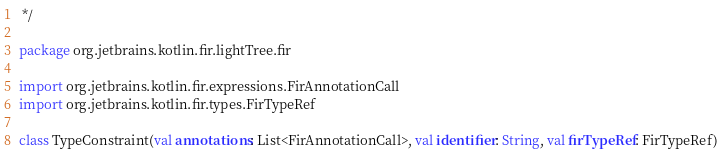Convert code to text. <code><loc_0><loc_0><loc_500><loc_500><_Kotlin_> */

package org.jetbrains.kotlin.fir.lightTree.fir

import org.jetbrains.kotlin.fir.expressions.FirAnnotationCall
import org.jetbrains.kotlin.fir.types.FirTypeRef

class TypeConstraint(val annotations: List<FirAnnotationCall>, val identifier: String, val firTypeRef: FirTypeRef)</code> 